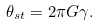Convert formula to latex. <formula><loc_0><loc_0><loc_500><loc_500>\theta _ { s t } = 2 \pi G \gamma .</formula> 